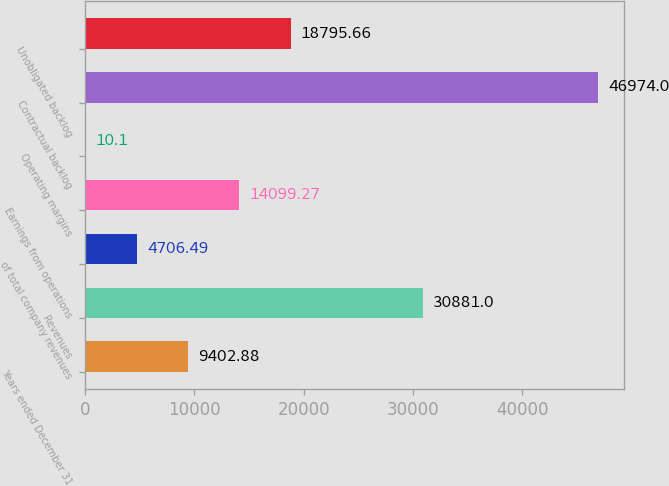Convert chart to OTSL. <chart><loc_0><loc_0><loc_500><loc_500><bar_chart><fcel>Years ended December 31<fcel>Revenues<fcel>of total company revenues<fcel>Earnings from operations<fcel>Operating margins<fcel>Contractual backlog<fcel>Unobligated backlog<nl><fcel>9402.88<fcel>30881<fcel>4706.49<fcel>14099.3<fcel>10.1<fcel>46974<fcel>18795.7<nl></chart> 